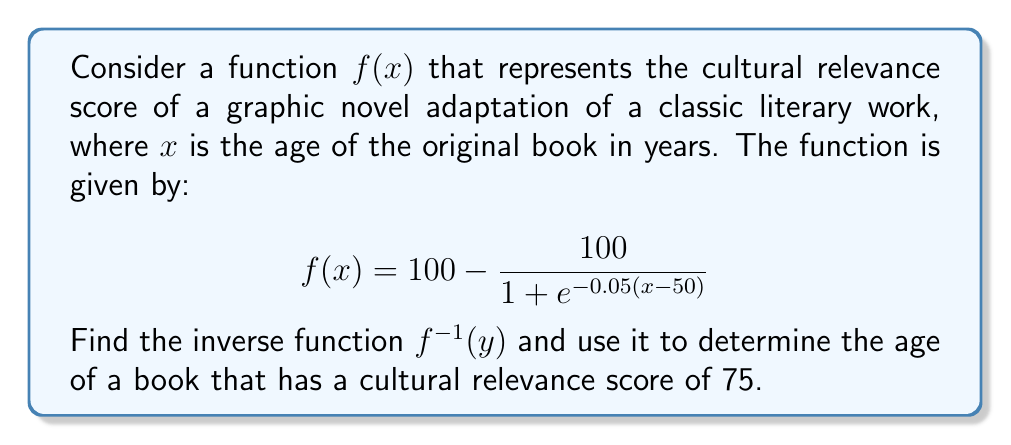Provide a solution to this math problem. To find the inverse function and solve this problem, we'll follow these steps:

1) First, we need to solve the equation $y = f(x)$ for $x$ in terms of $y$:

   $$y = 100 - \frac{100}{1 + e^{-0.05(x-50)}}$$

2) Subtract both sides from 100:

   $$100 - y = \frac{100}{1 + e^{-0.05(x-50)}}$$

3) Take the reciprocal of both sides:

   $$\frac{100}{100-y} = 1 + e^{-0.05(x-50)}$$

4) Subtract 1 from both sides:

   $$\frac{100}{100-y} - 1 = e^{-0.05(x-50)}$$

5) Take the natural log of both sides:

   $$\ln\left(\frac{100}{100-y} - 1\right) = -0.05(x-50)$$

6) Divide both sides by -0.05:

   $$-20\ln\left(\frac{100}{100-y} - 1\right) = x-50$$

7) Add 50 to both sides:

   $$50 - 20\ln\left(\frac{100}{100-y} - 1\right) = x$$

8) Therefore, the inverse function is:

   $$f^{-1}(y) = 50 - 20\ln\left(\frac{100}{100-y} - 1\right)$$

9) To find the age of a book with a cultural relevance score of 75, we substitute y = 75 into our inverse function:

   $$f^{-1}(75) = 50 - 20\ln\left(\frac{100}{100-75} - 1\right)$$

10) Simplify:

    $$f^{-1}(75) = 50 - 20\ln\left(\frac{100}{25} - 1\right) = 50 - 20\ln(3)$$

11) Calculate the final result:

    $$f^{-1}(75) \approx 50 - 20(1.0986) \approx 28.028$$
Answer: The inverse function is $f^{-1}(y) = 50 - 20\ln\left(\frac{100}{100-y} - 1\right)$, and the age of a book with a cultural relevance score of 75 is approximately 28 years. 